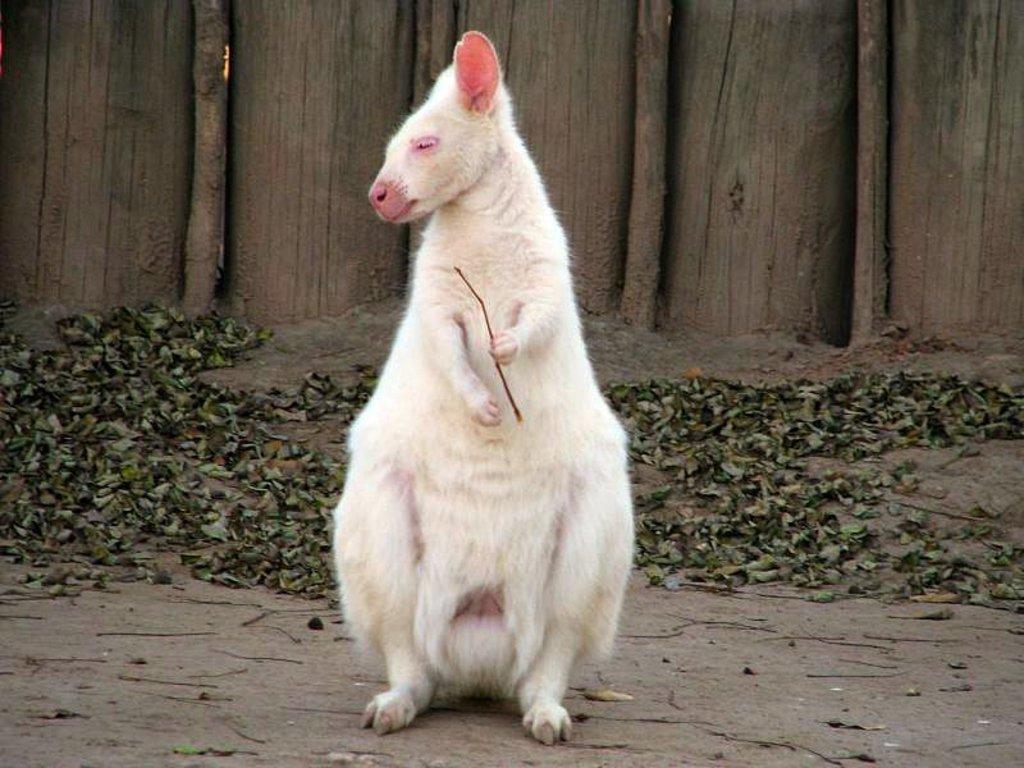Describe this image in one or two sentences. In this picture there is an animal standing and holding the stick which is in white color. At the back there are trees. At the bottom there are dried leaves. 